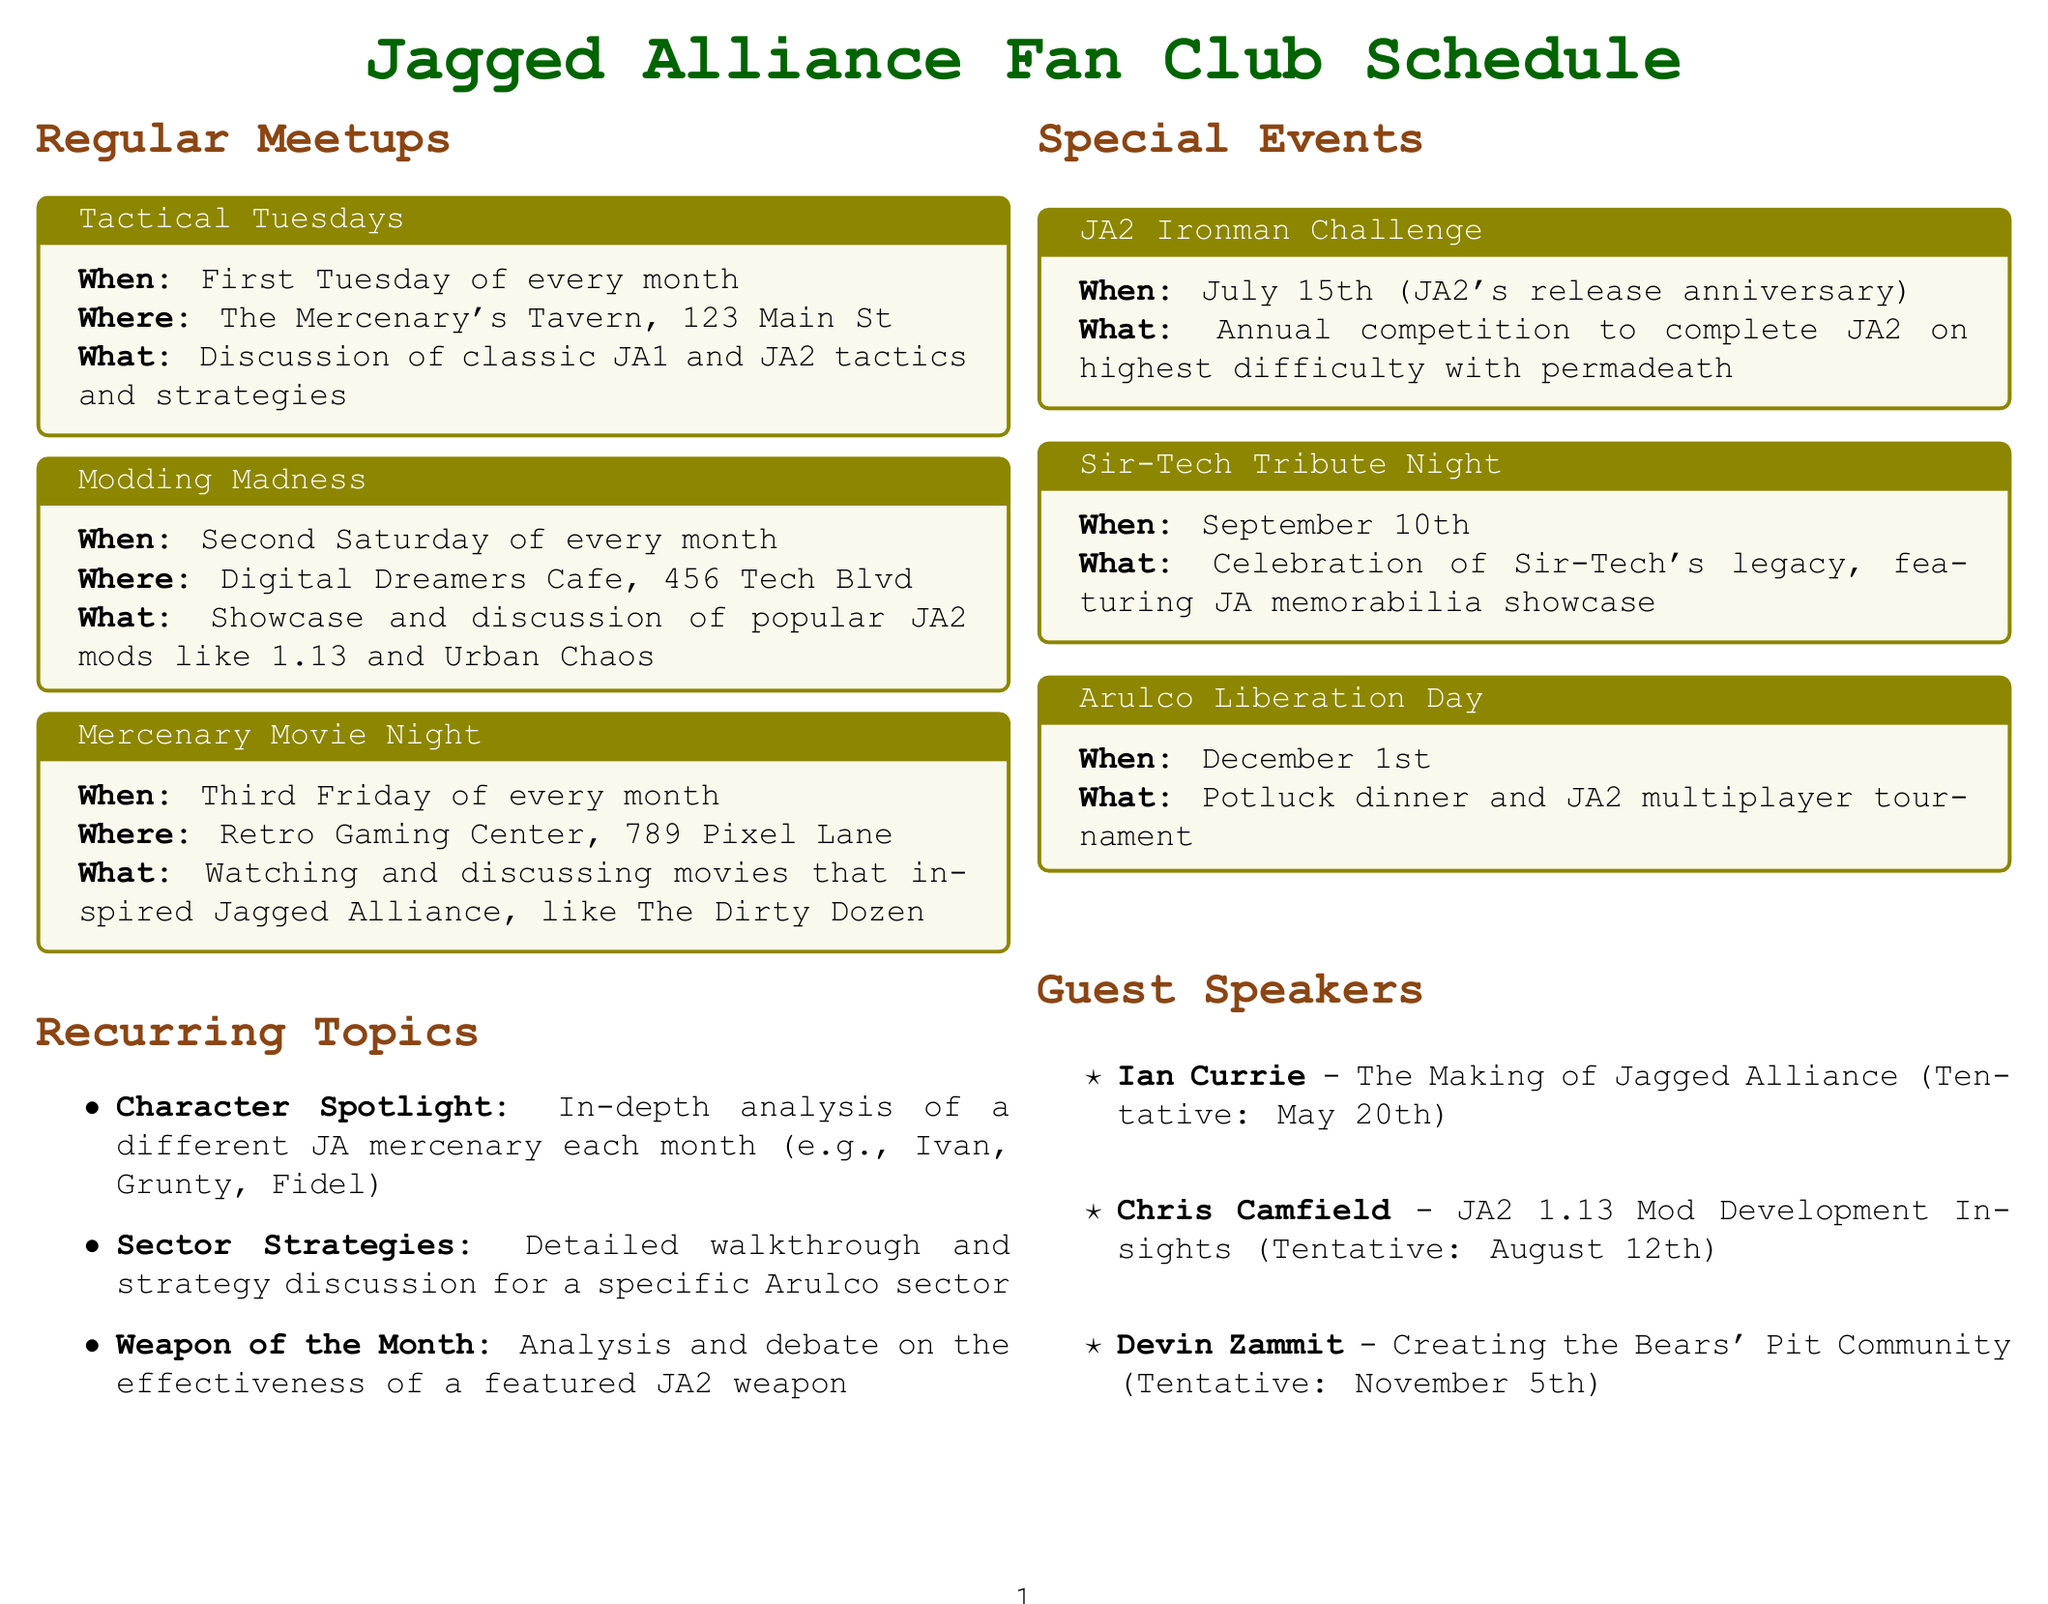what is the location for Tactical Tuesdays? The location for Tactical Tuesdays is specified in the document as The Mercenary's Tavern, 123 Main St.
Answer: The Mercenary's Tavern, 123 Main St when is the JA2 Ironman Challenge? The date for the JA2 Ironman Challenge is given in the document. It is scheduled on July 15th.
Answer: July 15th what is the main discussion topic for Modding Madness? The document outlines that Modding Madness focuses on a specific theme, which is popular JA2 mods.
Answer: popular JA2 mods who is the guest speaker on May 20th? The document lists the tentative date and name of the guest speaker for May 20th.
Answer: Ian Currie how often do meetings occur? The document specifies the frequency of regular meetups, indicating they are held every month.
Answer: every month what is the theme for the Character Spotlight? The document states that the Character Spotlight discusses a specific subject each month.
Answer: a different JA mercenary when is Arulco Liberation Day? The date for Arulco Liberation Day is explicitly mentioned in the document.
Answer: December 1st how many regular meetups are mentioned in the document? By counting the regular meetups provided in the document, we can find the total.
Answer: three what kind of event is the Sir-Tech Tribute Night? The document describes the nature of the Sir-Tech Tribute Night event.
Answer: Celebration of Sir-Tech's legacy 